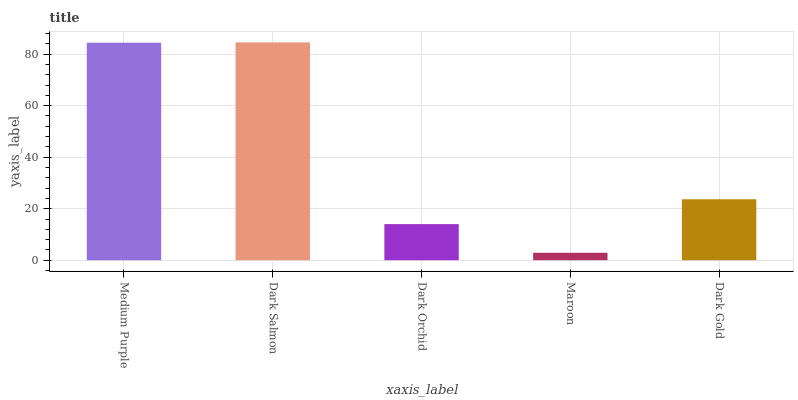Is Maroon the minimum?
Answer yes or no. Yes. Is Dark Salmon the maximum?
Answer yes or no. Yes. Is Dark Orchid the minimum?
Answer yes or no. No. Is Dark Orchid the maximum?
Answer yes or no. No. Is Dark Salmon greater than Dark Orchid?
Answer yes or no. Yes. Is Dark Orchid less than Dark Salmon?
Answer yes or no. Yes. Is Dark Orchid greater than Dark Salmon?
Answer yes or no. No. Is Dark Salmon less than Dark Orchid?
Answer yes or no. No. Is Dark Gold the high median?
Answer yes or no. Yes. Is Dark Gold the low median?
Answer yes or no. Yes. Is Maroon the high median?
Answer yes or no. No. Is Dark Salmon the low median?
Answer yes or no. No. 